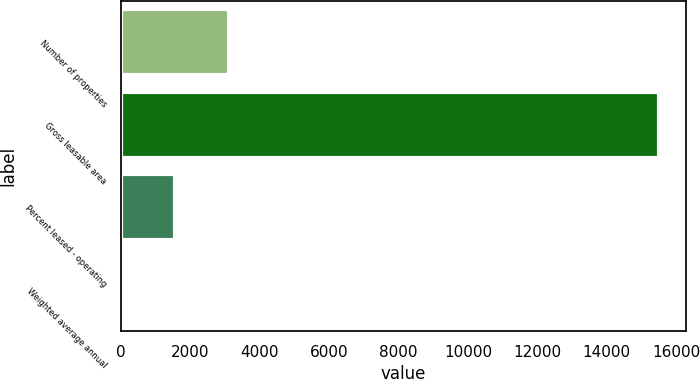<chart> <loc_0><loc_0><loc_500><loc_500><bar_chart><fcel>Number of properties<fcel>Gross leasable area<fcel>Percent leased - operating<fcel>Weighted average annual<nl><fcel>3115.48<fcel>15508<fcel>1566.41<fcel>17.34<nl></chart> 